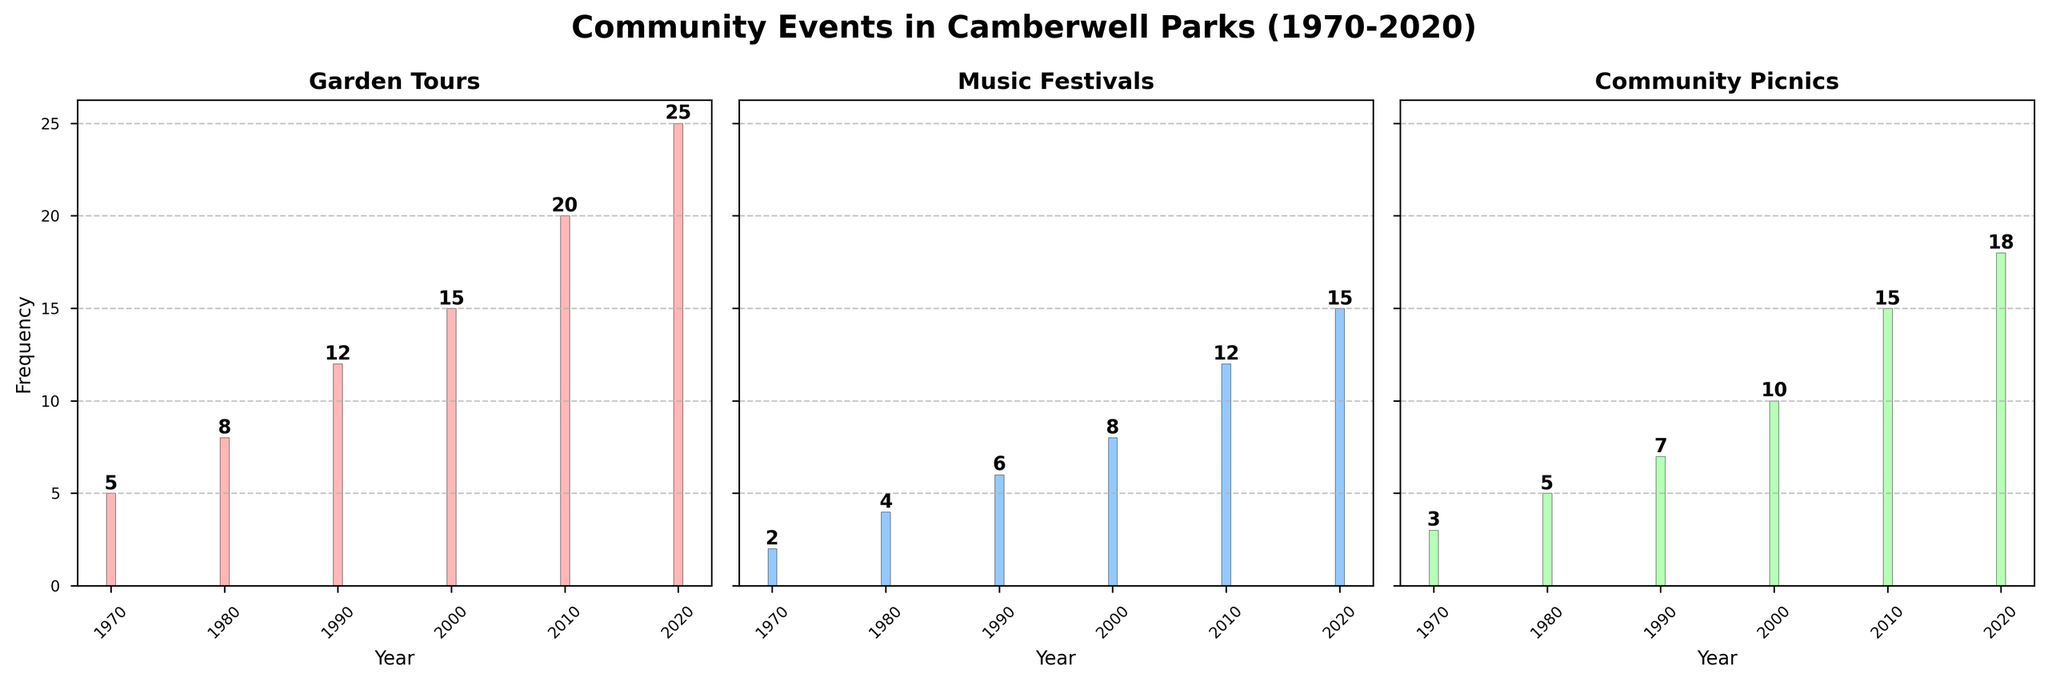What is the title of the overall figure? The title of the figure is located at the top center of the plot and describes the data being visualized.
Answer: Community Events in Camberwell Parks (1970-2020) Which event type had the highest frequency in 2020? By looking at the bars corresponding to the year 2020 in each subplot, we can see that Garden Tours has a frequency of 25, which is the highest among the three event types in that year.
Answer: Garden Tours How many more Music Festivals were held in 2010 compared to 1980? Find the frequency of Music Festivals in 2010 (12) and in 1980 (4). Calculate the difference: 12 - 4.
Answer: 8 Which year had the highest number of Community Picnics? Check the heights of the bars in the Community Picnics subplot. The highest bar corresponds to the year 2020 with a frequency of 18.
Answer: 2020 How has the frequency of Garden Tours changed from 1970 to 2020? Note the frequency of Garden Tours in 1970 (5) and 2020 (25). The change is 25 - 5 = 20, indicating a significant increase.
Answer: Increased by 20 What is the average frequency of Music Festivals over the five decades shown? Add the frequencies of Music Festivals for all years (2, 4, 6, 8, 12, 15), then divide by the number of years (5): (2 + 4 + 6 + 8 + 12 + 15) / 6.
Answer: 7.83 Between 2000 and 2020, which event type showed the greatest increase in frequency? Calculate the difference in frequencies between 2020 and 2000 for each event type: 
Garden Tours: 25 - 15 = 10, Music Festivals: 15 - 8 = 7, Community Picnics: 18 - 10 = 8. Garden Tours shows the greatest increase.
Answer: Garden Tours Has there been a consistent increase in the number of Community Picnics over the decades? Check the frequencies for Community Picnics over the years 1970, 1980, 1990, 2000, 2010, and 2020. Each subsequent year shows an increase: 3, 5, 7, 10, 15, 18.
Answer: Yes Which event type had the least frequency in 1970? Compare the frequencies for each event type in 1970: Garden Tours (5), Music Festivals (2), Community Picnics (3). Music Festivals had the least frequency.
Answer: Music Festivals What is the total frequency of Garden Tours reported in the figure? Sum the frequencies of Garden Tours over all years: 5 + 8 + 12 + 15 + 20 + 25 = 85.
Answer: 85 